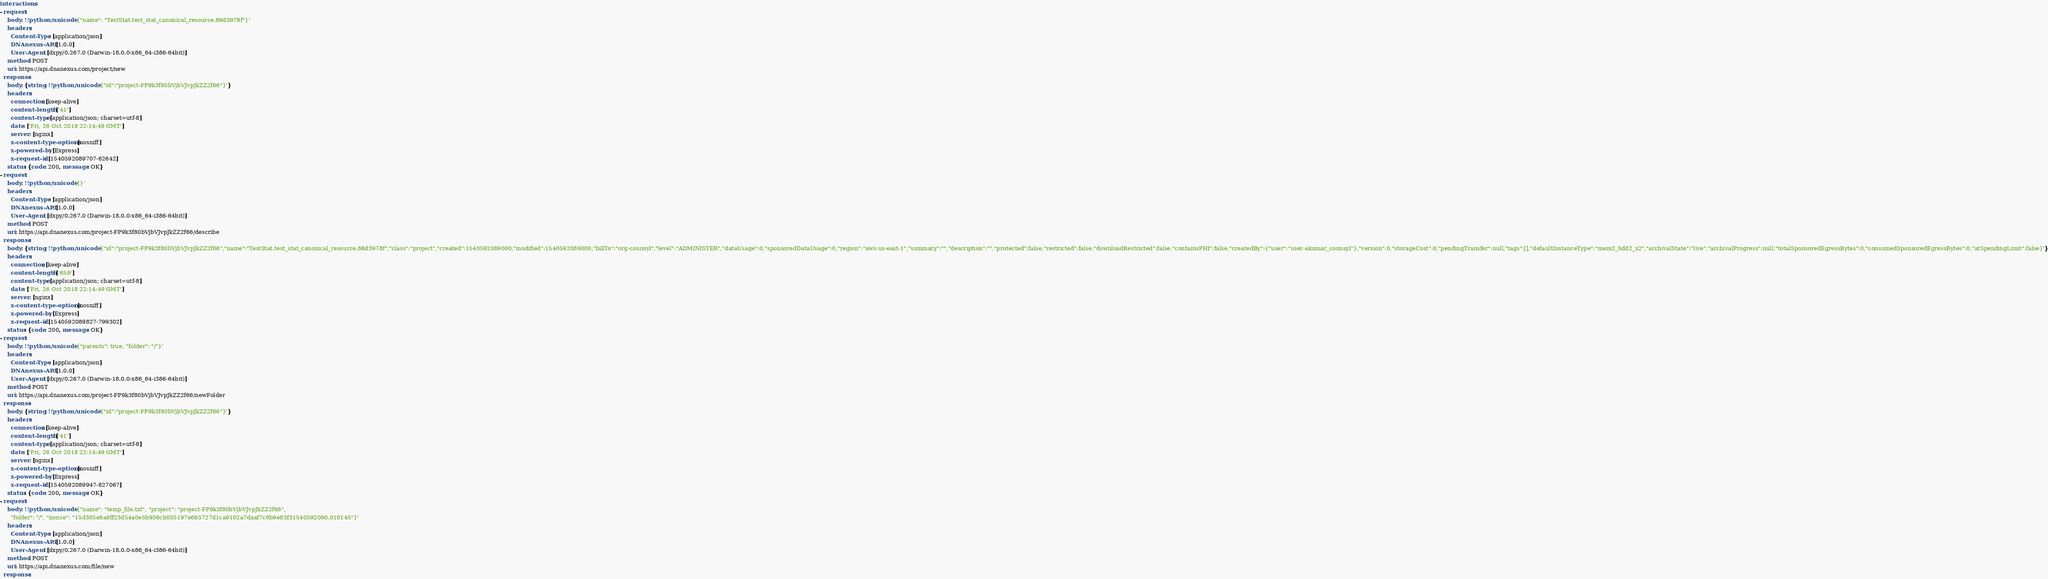Convert code to text. <code><loc_0><loc_0><loc_500><loc_500><_YAML_>interactions:
- request:
    body: !!python/unicode '{"name": "TestStat.test_stat_canonical_resource.86d3978f"}'
    headers:
      Content-Type: [application/json]
      DNAnexus-API: [1.0.0]
      User-Agent: [dxpy/0.267.0 (Darwin-18.0.0-x86_64-i386-64bit)]
    method: POST
    uri: https://api.dnanexus.com/project/new
  response:
    body: {string: !!python/unicode '{"id":"project-FP9k3f80bVjbVJvpJkZZ2f66"}'}
    headers:
      connection: [keep-alive]
      content-length: ['41']
      content-type: [application/json; charset=utf-8]
      date: ['Fri, 26 Oct 2018 22:14:49 GMT']
      server: [nginx]
      x-content-type-options: [nosniff]
      x-powered-by: [Express]
      x-request-id: [1540592089707-62642]
    status: {code: 200, message: OK}
- request:
    body: !!python/unicode '{}'
    headers:
      Content-Type: [application/json]
      DNAnexus-API: [1.0.0]
      User-Agent: [dxpy/0.267.0 (Darwin-18.0.0-x86_64-i386-64bit)]
    method: POST
    uri: https://api.dnanexus.com/project-FP9k3f80bVjbVJvpJkZZ2f66/describe
  response:
    body: {string: !!python/unicode '{"id":"project-FP9k3f80bVjbVJvpJkZZ2f66","name":"TestStat.test_stat_canonical_resource.86d3978f","class":"project","created":1540592089000,"modified":1540592089000,"billTo":"org-counsyl","level":"ADMINISTER","dataUsage":0,"sponsoredDataUsage":0,"region":"aws:us-east-1","summary":"","description":"","protected":false,"restricted":false,"downloadRestricted":false,"containsPHI":false,"createdBy":{"user":"user-akumar_counsyl"},"version":0,"storageCost":0,"pendingTransfer":null,"tags":[],"defaultInstanceType":"mem2_hdd2_x2","archivalState":"live","archivalProgress":null,"totalSponsoredEgressBytes":0,"consumedSponsoredEgressBytes":0,"atSpendingLimit":false}'}
    headers:
      connection: [keep-alive]
      content-length: ['659']
      content-type: [application/json; charset=utf-8]
      date: ['Fri, 26 Oct 2018 22:14:49 GMT']
      server: [nginx]
      x-content-type-options: [nosniff]
      x-powered-by: [Express]
      x-request-id: [1540592089827-799302]
    status: {code: 200, message: OK}
- request:
    body: !!python/unicode '{"parents": true, "folder": "/"}'
    headers:
      Content-Type: [application/json]
      DNAnexus-API: [1.0.0]
      User-Agent: [dxpy/0.267.0 (Darwin-18.0.0-x86_64-i386-64bit)]
    method: POST
    uri: https://api.dnanexus.com/project-FP9k3f80bVjbVJvpJkZZ2f66/newFolder
  response:
    body: {string: !!python/unicode '{"id":"project-FP9k3f80bVjbVJvpJkZZ2f66"}'}
    headers:
      connection: [keep-alive]
      content-length: ['41']
      content-type: [application/json; charset=utf-8]
      date: ['Fri, 26 Oct 2018 22:14:49 GMT']
      server: [nginx]
      x-content-type-options: [nosniff]
      x-powered-by: [Express]
      x-request-id: [1540592089947-827067]
    status: {code: 200, message: OK}
- request:
    body: !!python/unicode '{"name": "temp_file.txt", "project": "project-FP9k3f80bVjbVJvpJkZZ2f66",
      "folder": "/", "nonce": "15d305e8a9ff23d54a0e5b956cb035197e665727d1ca9102a7daaf7c6b9e83f31540592090.010145"}'
    headers:
      Content-Type: [application/json]
      DNAnexus-API: [1.0.0]
      User-Agent: [dxpy/0.267.0 (Darwin-18.0.0-x86_64-i386-64bit)]
    method: POST
    uri: https://api.dnanexus.com/file/new
  response:</code> 